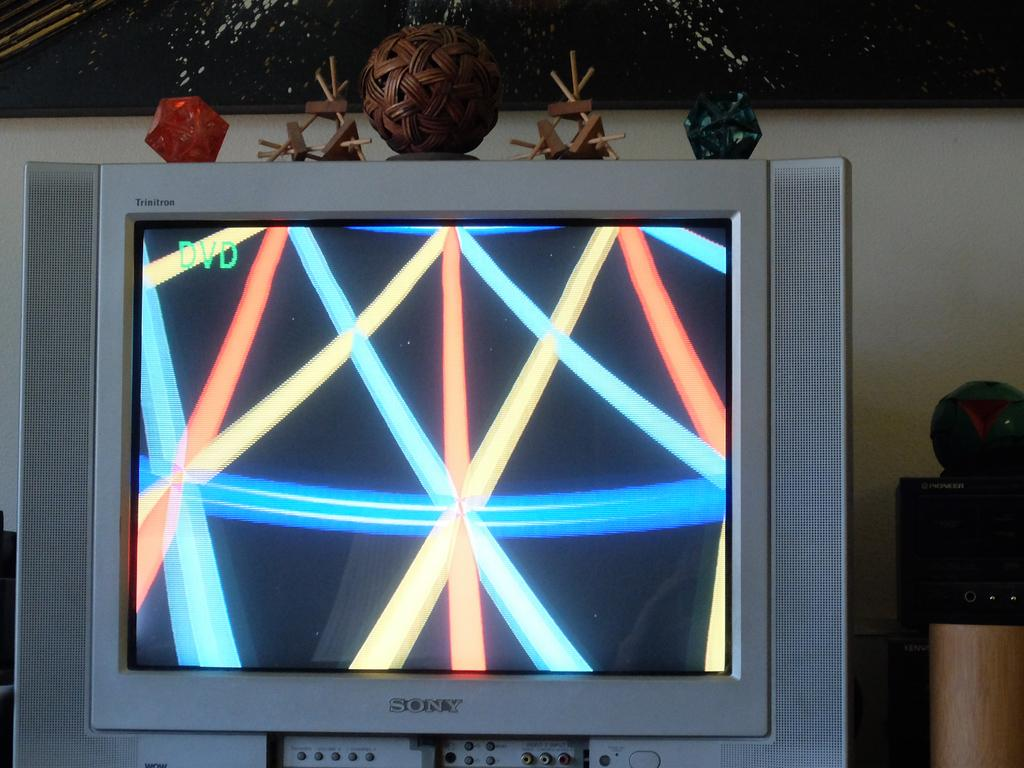<image>
Describe the image concisely. An old Sony TV with lines being displayed 